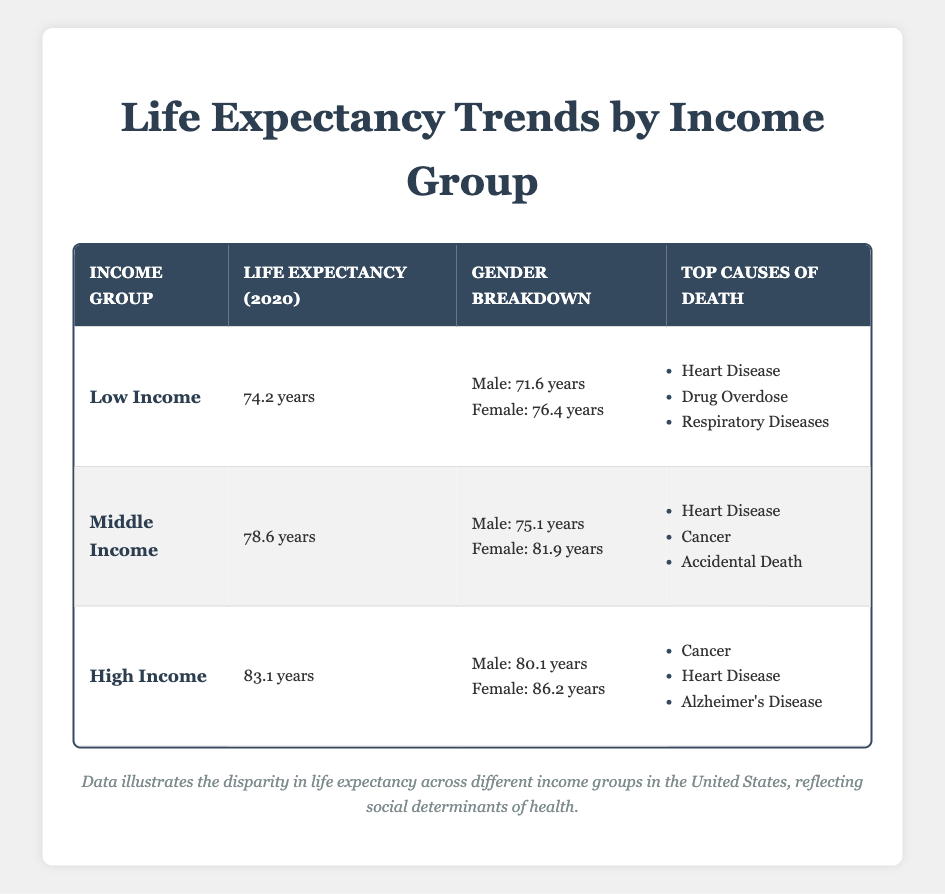What is the life expectancy for the high-income group in 2020? According to the table, the life expectancy for the high-income group in 2020 is listed directly under that category. It states that the value is 83.1 years.
Answer: 83.1 years Which income group has the highest life expectancy for females? The life expectancy for females is provided for each income group. The high-income group has a female life expectancy of 86.2 years, which is higher than the 76.4 years for low income and 81.9 years for middle income.
Answer: High Income What is the difference in life expectancy between low income and middle income groups? The life expectancy for the low income group is 74.2 years and for the middle income group is 78.6 years. To find the difference, we subtract 74.2 from 78.6, which equals 4.4 years.
Answer: 4.4 years Is it true that drug overdose is one of the top causes of death for the middle income group? The table indicates that the top causes of death for the middle income group are heart disease, cancer, and accidental death. Drug overdose is not listed among these causes. Thus, this statement is false.
Answer: No What are the top three causes of death for the low-income group, and how do they compare with the high-income group's causes of death? The top three causes of death for the low-income group include heart disease, drug overdose, and respiratory diseases. The high-income group's top causes include cancer, heart disease, and Alzheimer's disease. Comparing these, both groups list heart disease, but the low-income group has drug overdose and respiratory diseases, while the high-income group has cancer and Alzheimer's disease, showing a different health profile based on income.
Answer: Low Income: Heart Disease, Drug Overdose, Respiratory Diseases; High Income: Cancer, Heart Disease, Alzheimer's Disease What is the average life expectancy across all income groups for the year 2020? To find the average life expectancy, we sum the life expectancies of each income group: 74.2 (low) + 78.6 (middle) + 83.1 (high) = 235.9 years. We then divide by 3 (the number of income groups) to get the average: 235.9 / 3 = 78.63 years.
Answer: 78.63 years Which gender in the middle-income group has a higher life expectancy, and by how much? The life expectancy for males in the middle-income group is 75.1 years, and for females, it is 81.9 years. To find the difference, we subtract the male life expectancy from the female life expectancy: 81.9 - 75.1 = 6.8 years.
Answer: Females; 6.8 years 